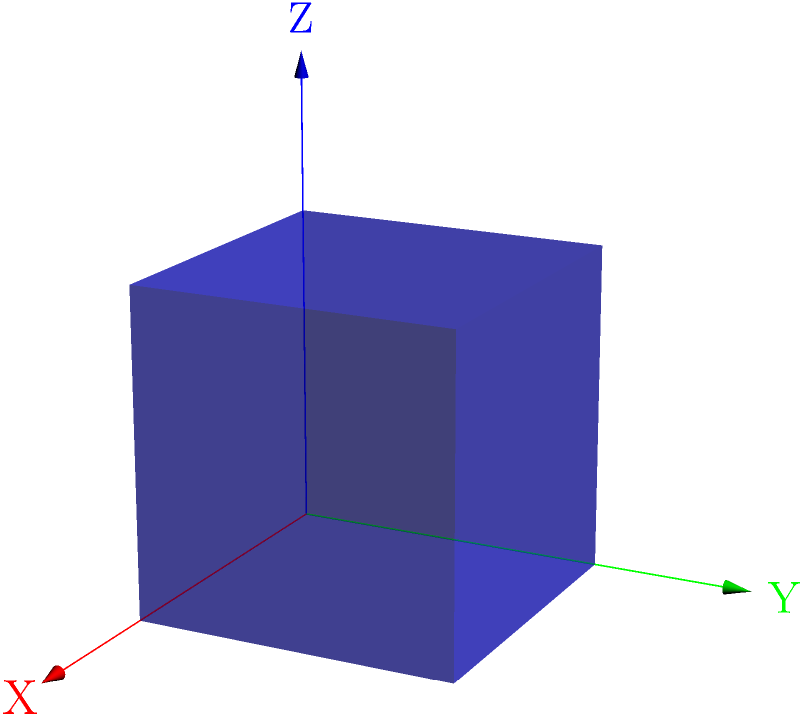In CSS, to create a 3D cube that rotates 45 degrees around both the X and Y axes, which transform functions would you use, and in what order? To create a rotating 3D cube in CSS, we need to follow these steps:

1. First, we need to set up the 3D space using `perspective` on the parent container.

2. For the cube itself, we use the `transform-style: preserve-3d` property to ensure its child elements (faces) maintain their position in 3D space.

3. To rotate the cube, we use the `transform` property with rotation functions. The order of transformations matters in CSS, as each transformation is applied in the order it's listed.

4. To rotate around the X-axis, we use `rotateX(45deg)`.

5. To rotate around the Y-axis, we use `rotateY(45deg)`.

6. The order should be Y-axis rotation first, then X-axis rotation. This is because we want the cube to first rotate around its vertical axis (Y), and then tilt forward/backward (X).

Therefore, the correct transform function would be:

```css
transform: rotateY(45deg) rotateX(45deg);
```

This order ensures that the cube first rotates around its vertical axis and then tilts, providing a more natural-looking rotation in 3D space.
Answer: rotateY(45deg) rotateX(45deg) 